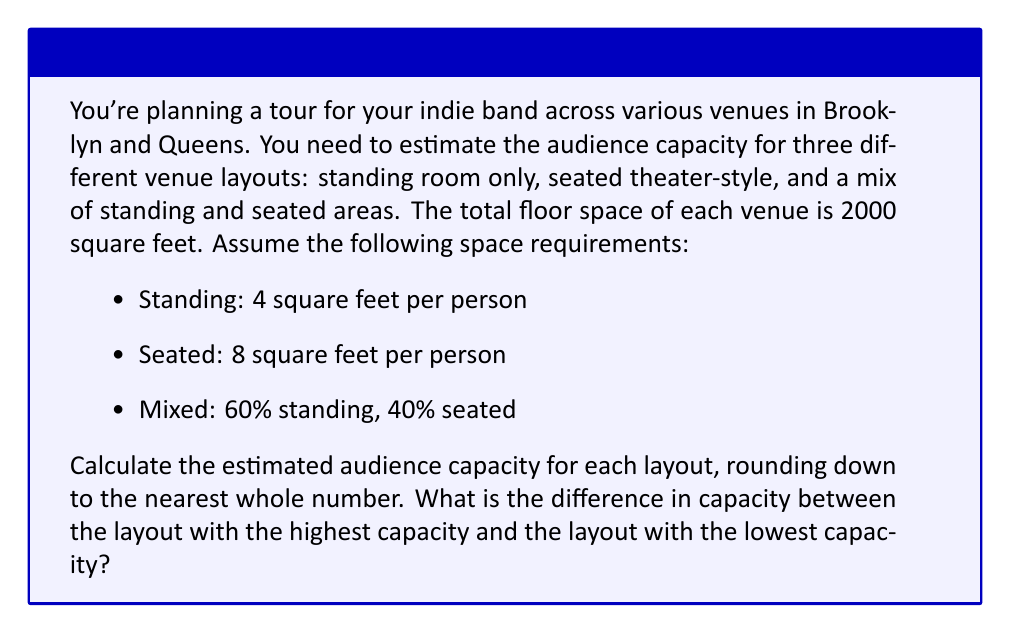Could you help me with this problem? Let's approach this problem step by step:

1. Standing room only layout:
   * Total area = 2000 sq ft
   * Space per person = 4 sq ft
   * Capacity = $\lfloor \frac{2000}{4} \rfloor = \lfloor 500 \rfloor = 500$ people

2. Seated theater-style layout:
   * Total area = 2000 sq ft
   * Space per person = 8 sq ft
   * Capacity = $\lfloor \frac{2000}{8} \rfloor = \lfloor 250 \rfloor = 250$ people

3. Mixed layout (60% standing, 40% seated):
   * Total area = 2000 sq ft
   * Standing area = 60% of 2000 = 1200 sq ft
   * Seated area = 40% of 2000 = 800 sq ft
   * Standing capacity = $\lfloor \frac{1200}{4} \rfloor = 300$ people
   * Seated capacity = $\lfloor \frac{800}{8} \rfloor = 100$ people
   * Total mixed capacity = 300 + 100 = 400 people

4. Comparing capacities:
   * Highest capacity: Standing room only (500 people)
   * Lowest capacity: Seated theater-style (250 people)
   * Difference = 500 - 250 = 250 people
Answer: The difference in capacity between the layout with the highest capacity (standing room only) and the layout with the lowest capacity (seated theater-style) is 250 people. 